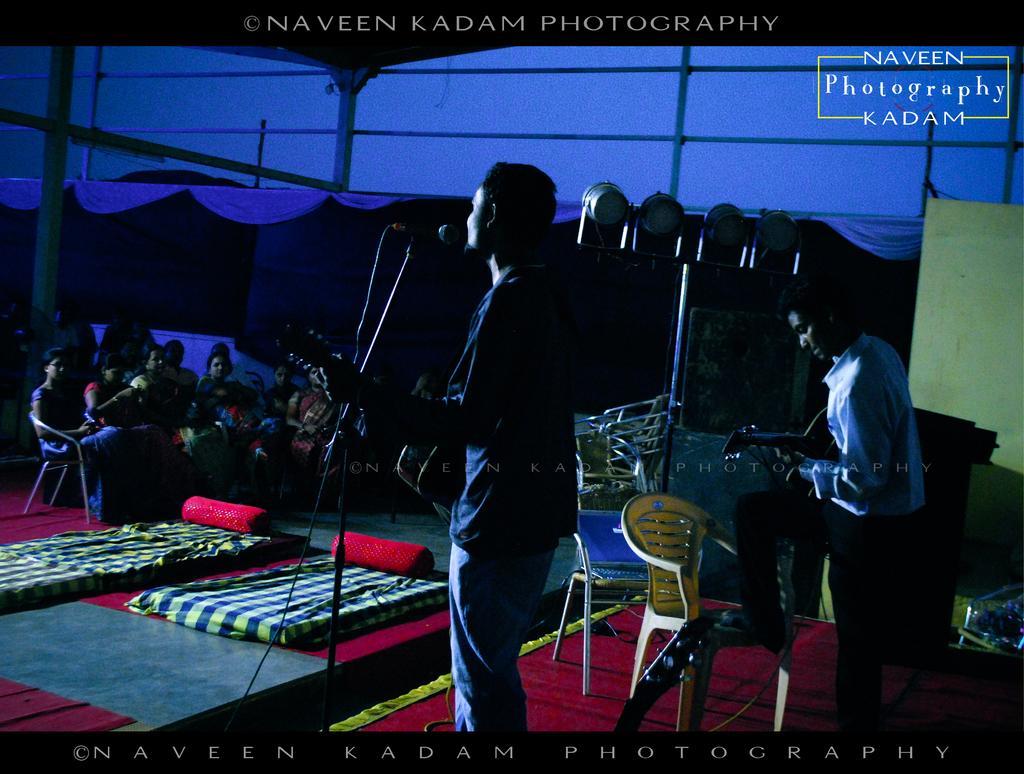Describe this image in one or two sentences. In this picture, we can see a few people sitting and one person is standing, and among them two persons are playing musical instruments, we can see the ground with some objects like chairs, mats, poles, lights, and we can see the background with poles, curtains, and we can see some text and water mark on top and bottom of the picture. 